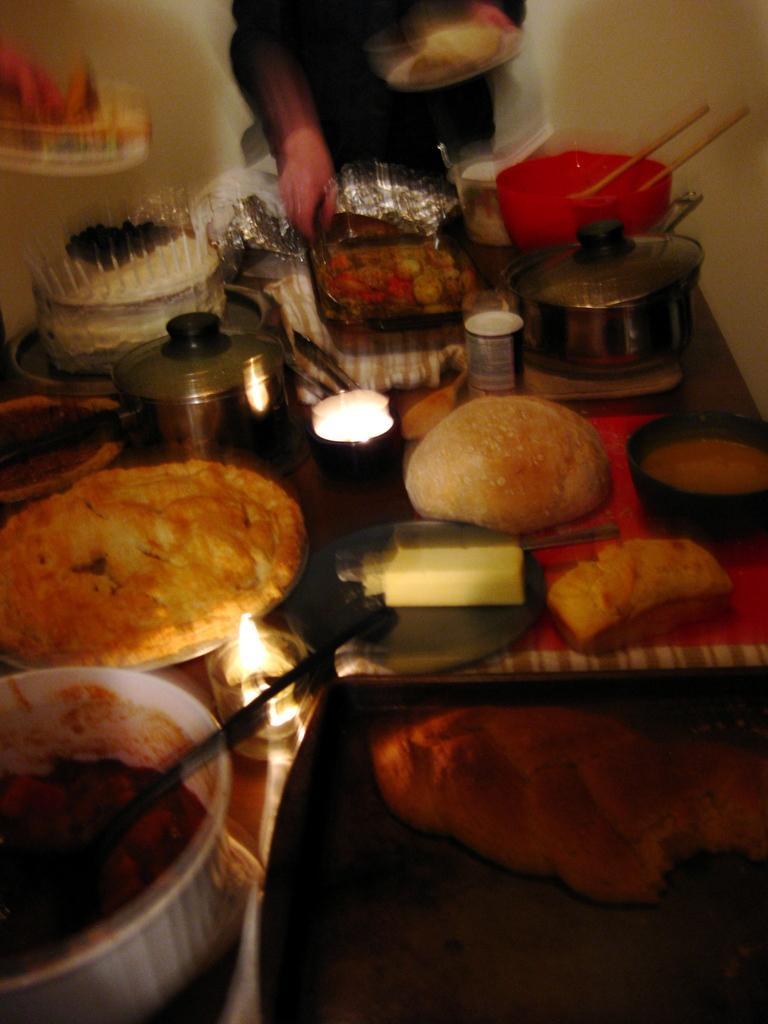How would you summarize this image in a sentence or two? In this image we can see a person holding an object, there is a table, on the table, we can see some bowls, bread, tin, boxes and other food items, in the background we can see the wall. 